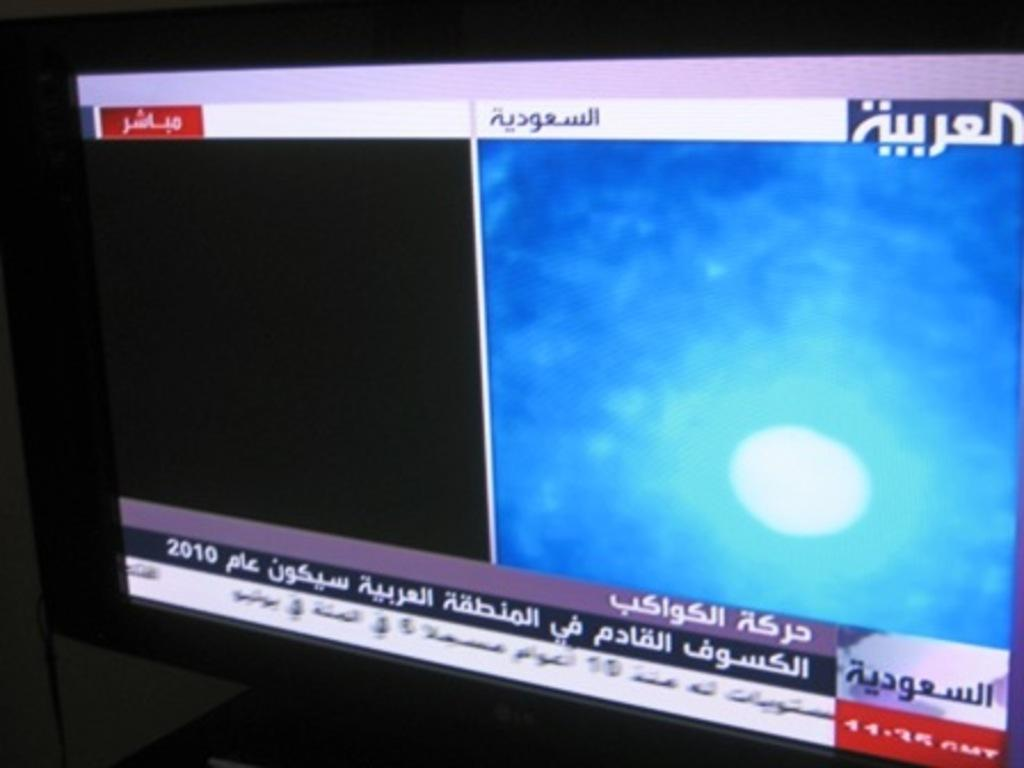<image>
Offer a succinct explanation of the picture presented. A blue and black computer screen has arabic writing. 